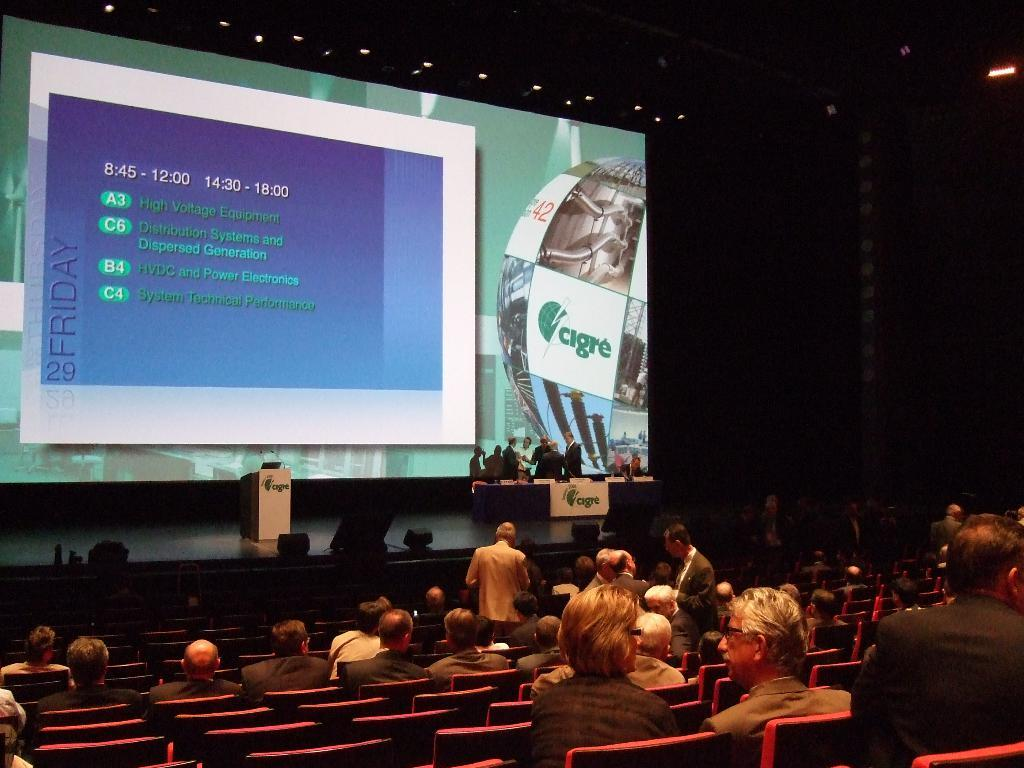Provide a one-sentence caption for the provided image. A conference room with people seated looking at a large screen with electric power bullet points. 